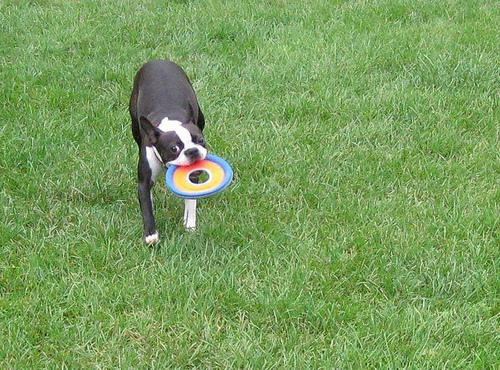Question: what is green?
Choices:
A. Fruit.
B. Water.
C. Grass.
D. Stones.
Answer with the letter. Answer: C Question: what is black and white?
Choices:
A. The cat.
B. The zebra.
C. The dog.
D. The skunk.
Answer with the letter. Answer: C Question: why is a dog holding a frisbee?
Choices:
A. To eat it.
B. To play.
C. To buy it.
D. To run away with it.
Answer with the letter. Answer: B Question: where is a frisbee?
Choices:
A. On the grass.
B. In a person's hand.
C. In a tree.
D. In a dog's mouth.
Answer with the letter. Answer: D Question: what is colorful?
Choices:
A. Kite.
B. Skateboard.
C. Frisbee.
D. Beach ball.
Answer with the letter. Answer: C Question: where was the photo taken?
Choices:
A. In the street.
B. At the picnic.
C. On grass.
D. At work.
Answer with the letter. Answer: C 